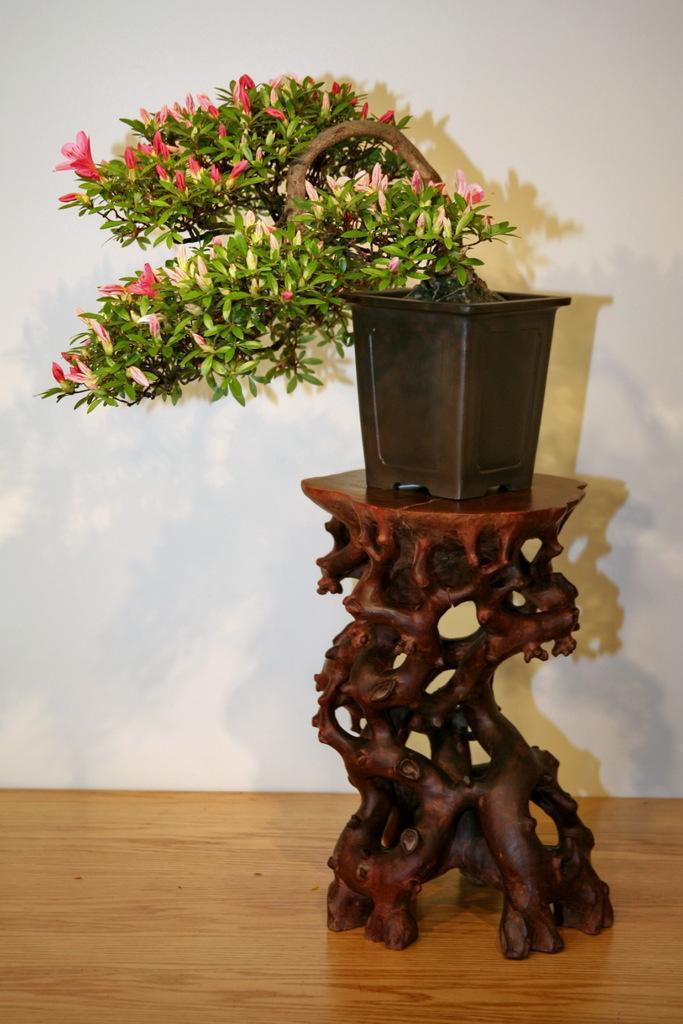Could you give a brief overview of what you see in this image? there is a house plant on the table 